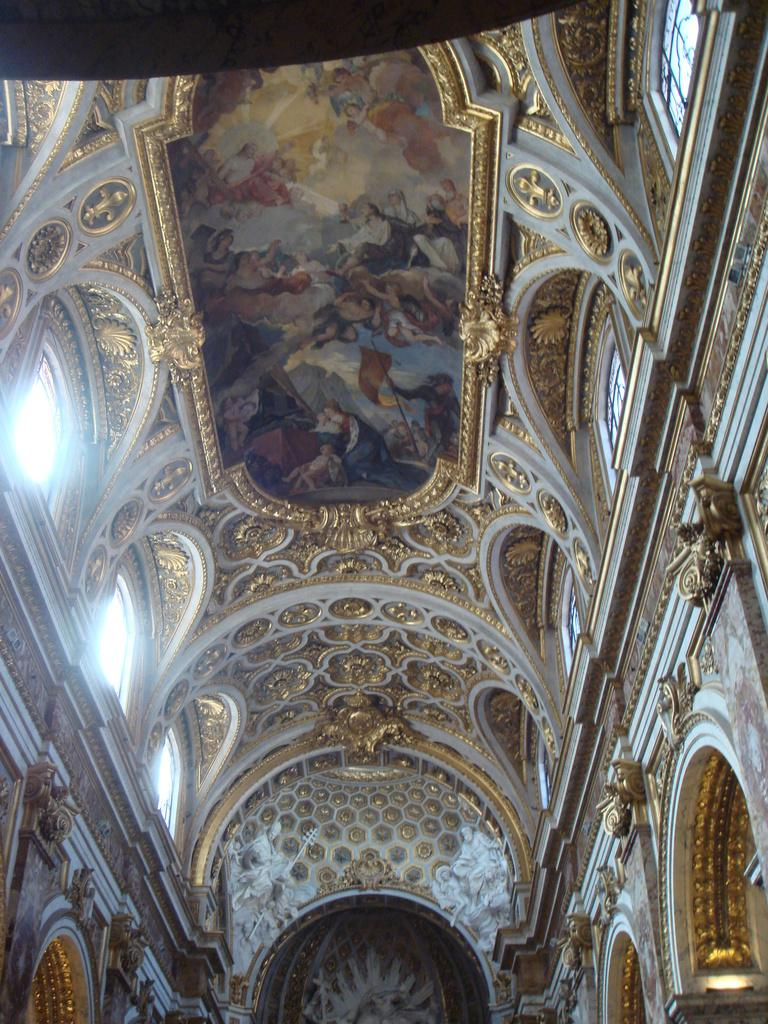What type of space is shown in the image? The image depicts the interior design of a building. What can be seen on the walls in the image? There are designs crafted on the walls. Are there any architectural features related to airflow in the image? Yes, ventilation windows are present in the image. What type of tail can be seen on the furniture in the image? There is no furniture with a tail present in the image. What kind of bait is used to attract visitors in the image? There is no bait present in the image, as it depicts the interior design of a building. 